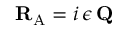Convert formula to latex. <formula><loc_0><loc_0><loc_500><loc_500>{ R } _ { A } = i \, \epsilon \, { Q }</formula> 